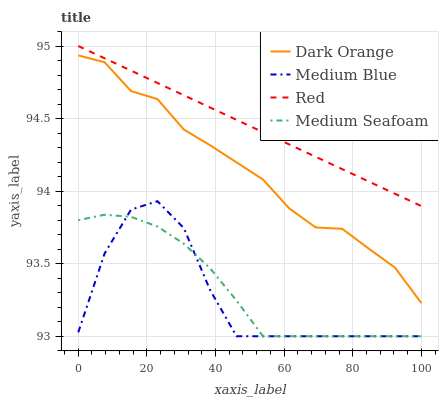Does Medium Seafoam have the minimum area under the curve?
Answer yes or no. No. Does Medium Seafoam have the maximum area under the curve?
Answer yes or no. No. Is Medium Seafoam the smoothest?
Answer yes or no. No. Is Medium Seafoam the roughest?
Answer yes or no. No. Does Red have the lowest value?
Answer yes or no. No. Does Medium Blue have the highest value?
Answer yes or no. No. Is Dark Orange less than Red?
Answer yes or no. Yes. Is Red greater than Medium Blue?
Answer yes or no. Yes. Does Dark Orange intersect Red?
Answer yes or no. No. 